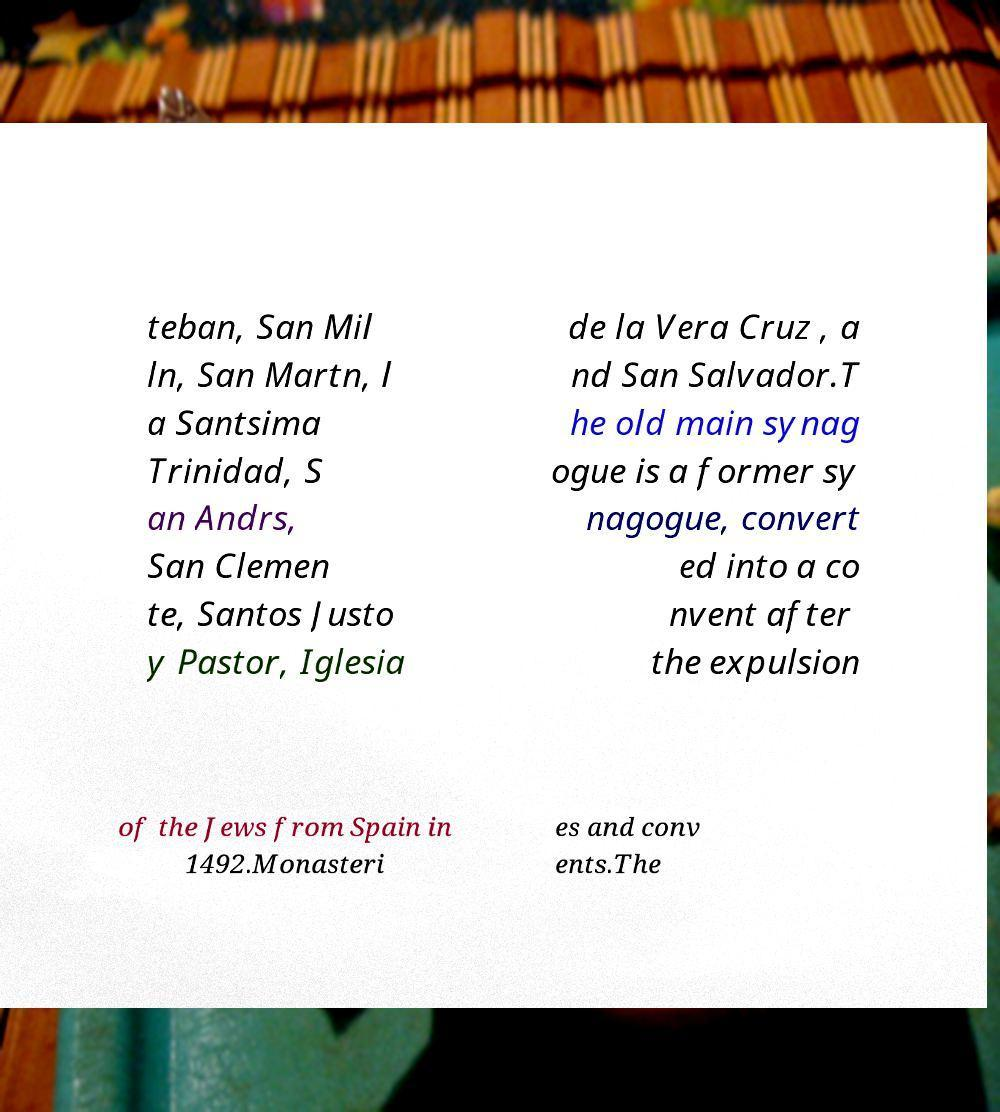There's text embedded in this image that I need extracted. Can you transcribe it verbatim? teban, San Mil ln, San Martn, l a Santsima Trinidad, S an Andrs, San Clemen te, Santos Justo y Pastor, Iglesia de la Vera Cruz , a nd San Salvador.T he old main synag ogue is a former sy nagogue, convert ed into a co nvent after the expulsion of the Jews from Spain in 1492.Monasteri es and conv ents.The 